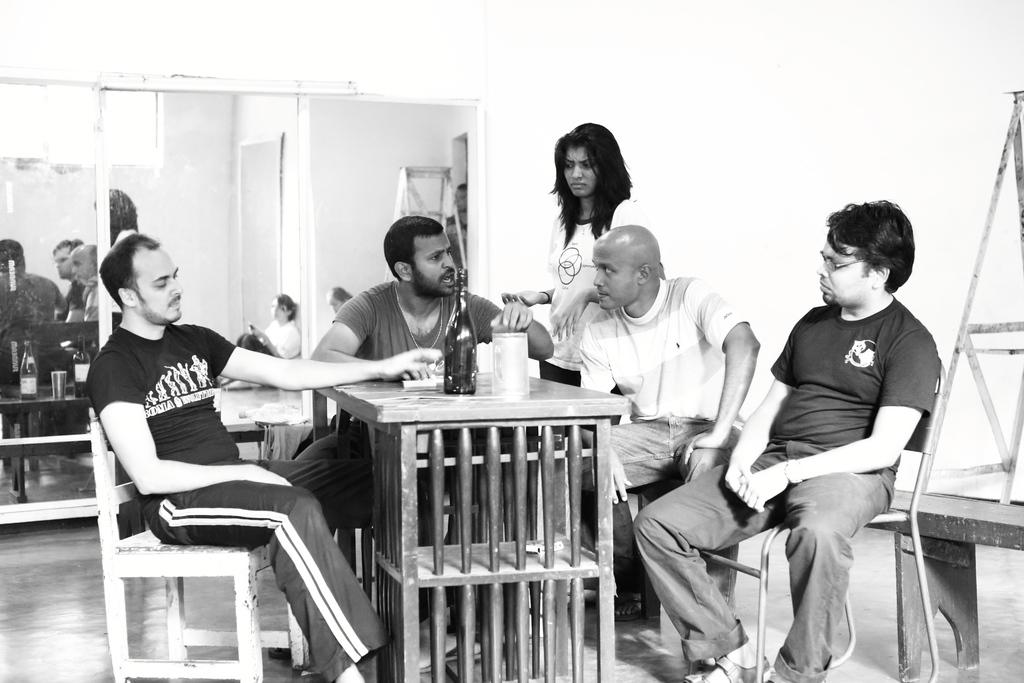What are the people in the image doing? The people in the image are sitting on chairs at a table. Who is standing behind them? A woman is standing behind them. What objects can be seen on the table? There is a bottle and a jug in the image. What can be seen in the background of the image? There is a mirror and a wall in the background. What type of tin can be seen in the image? There is no tin present in the image. How does the zephyr affect the people sitting at the table? There is no mention of a zephyr in the image, so it cannot affect the people sitting at the table. 